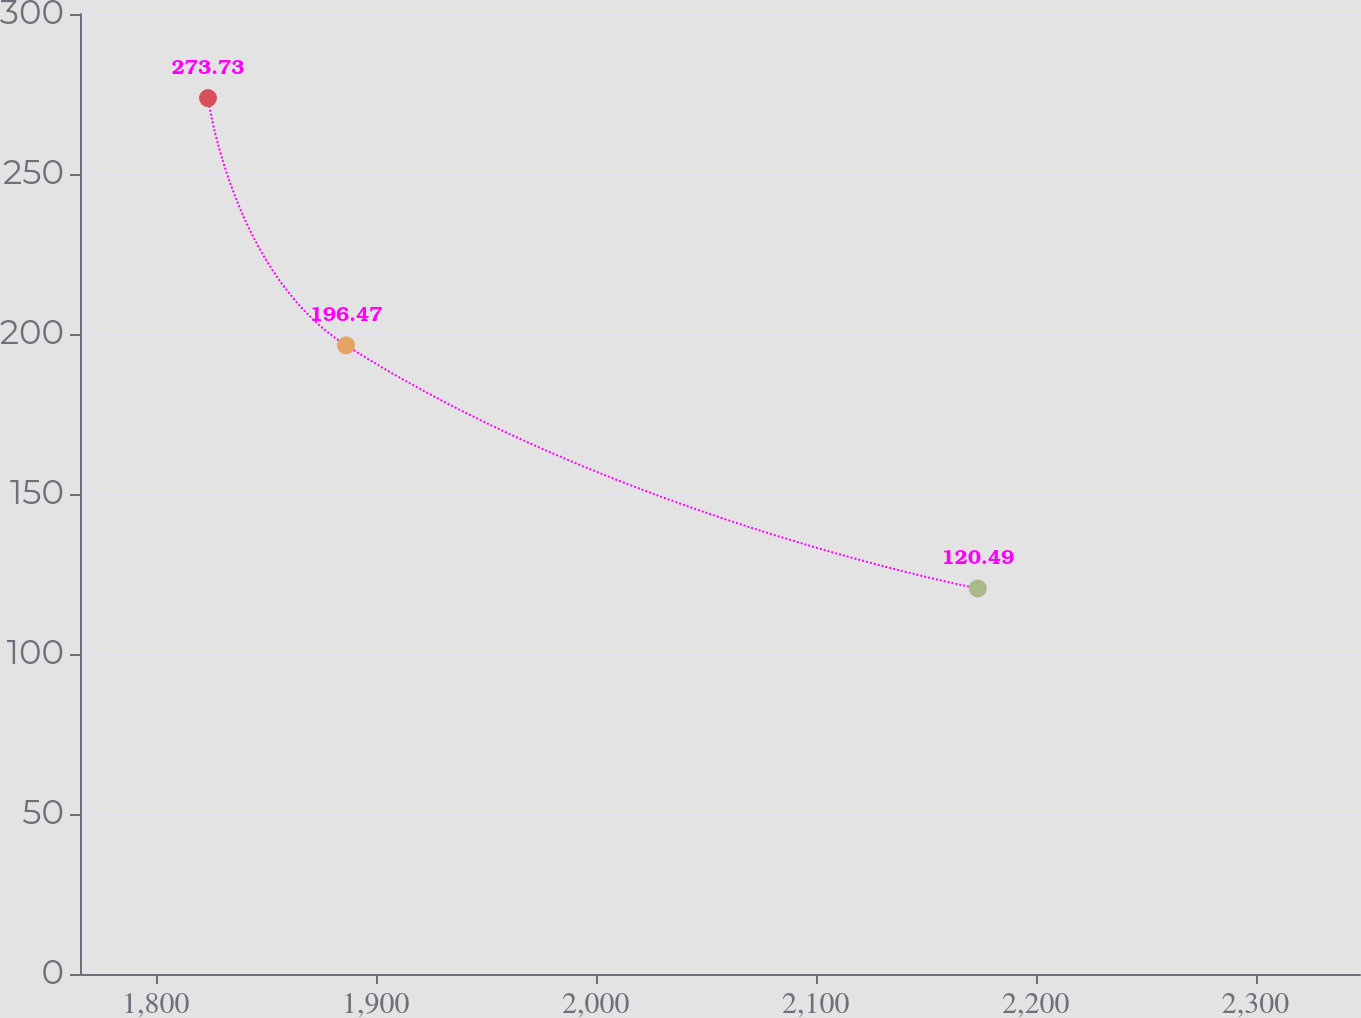Convert chart. <chart><loc_0><loc_0><loc_500><loc_500><line_chart><ecel><fcel>Unnamed: 1<nl><fcel>1823.71<fcel>273.73<nl><fcel>1886.47<fcel>196.47<nl><fcel>2173.7<fcel>120.49<nl><fcel>2351.72<fcel>79.03<nl><fcel>2405.66<fcel>56.44<nl></chart> 